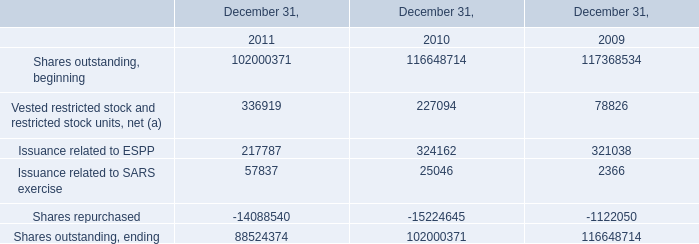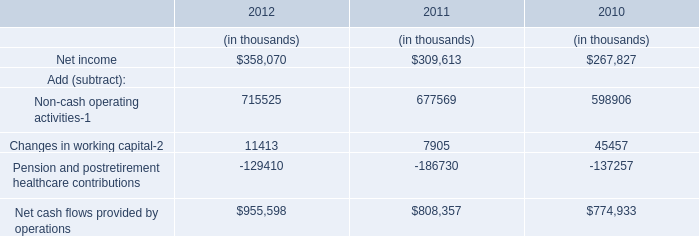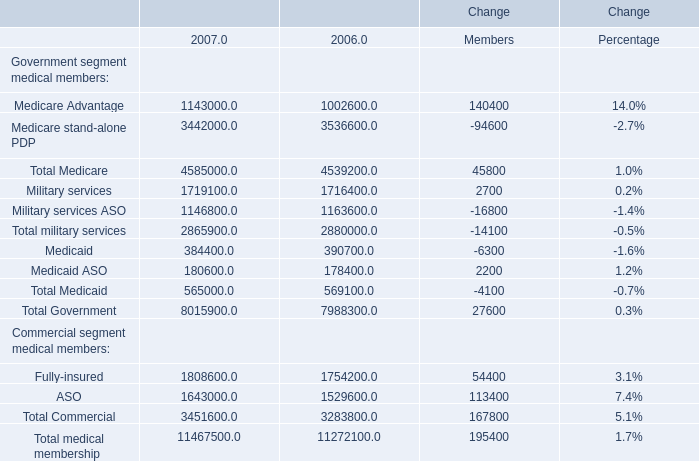Which year is the amount in terms of Total Medicaid the least? 
Answer: 2007. 